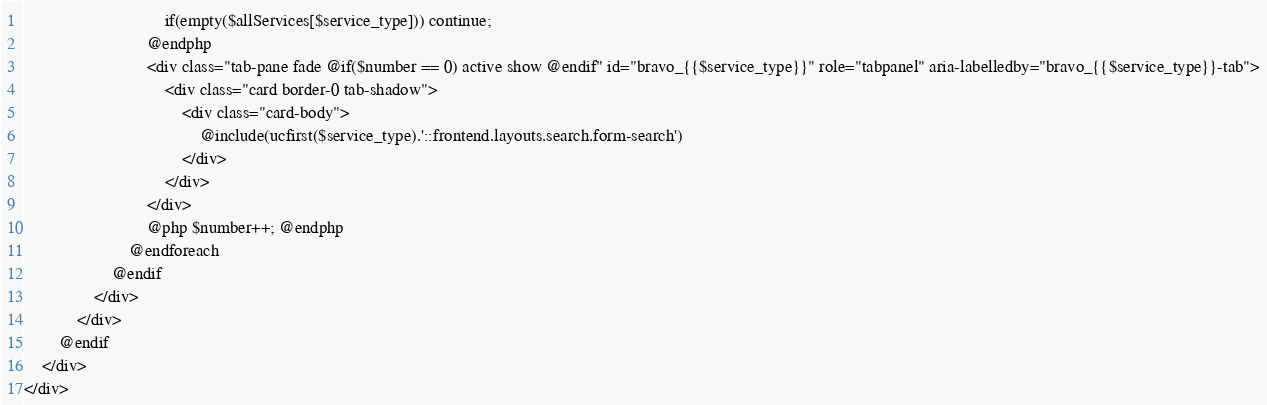<code> <loc_0><loc_0><loc_500><loc_500><_PHP_>                                if(empty($allServices[$service_type])) continue;
                            @endphp
                            <div class="tab-pane fade @if($number == 0) active show @endif" id="bravo_{{$service_type}}" role="tabpanel" aria-labelledby="bravo_{{$service_type}}-tab">
                                <div class="card border-0 tab-shadow">
                                    <div class="card-body">
                                        @include(ucfirst($service_type).'::frontend.layouts.search.form-search')
                                    </div>
                                </div>
                            </div>
                            @php $number++; @endphp
                        @endforeach
                    @endif
                </div>
            </div>
        @endif
    </div>
</div>
</code> 